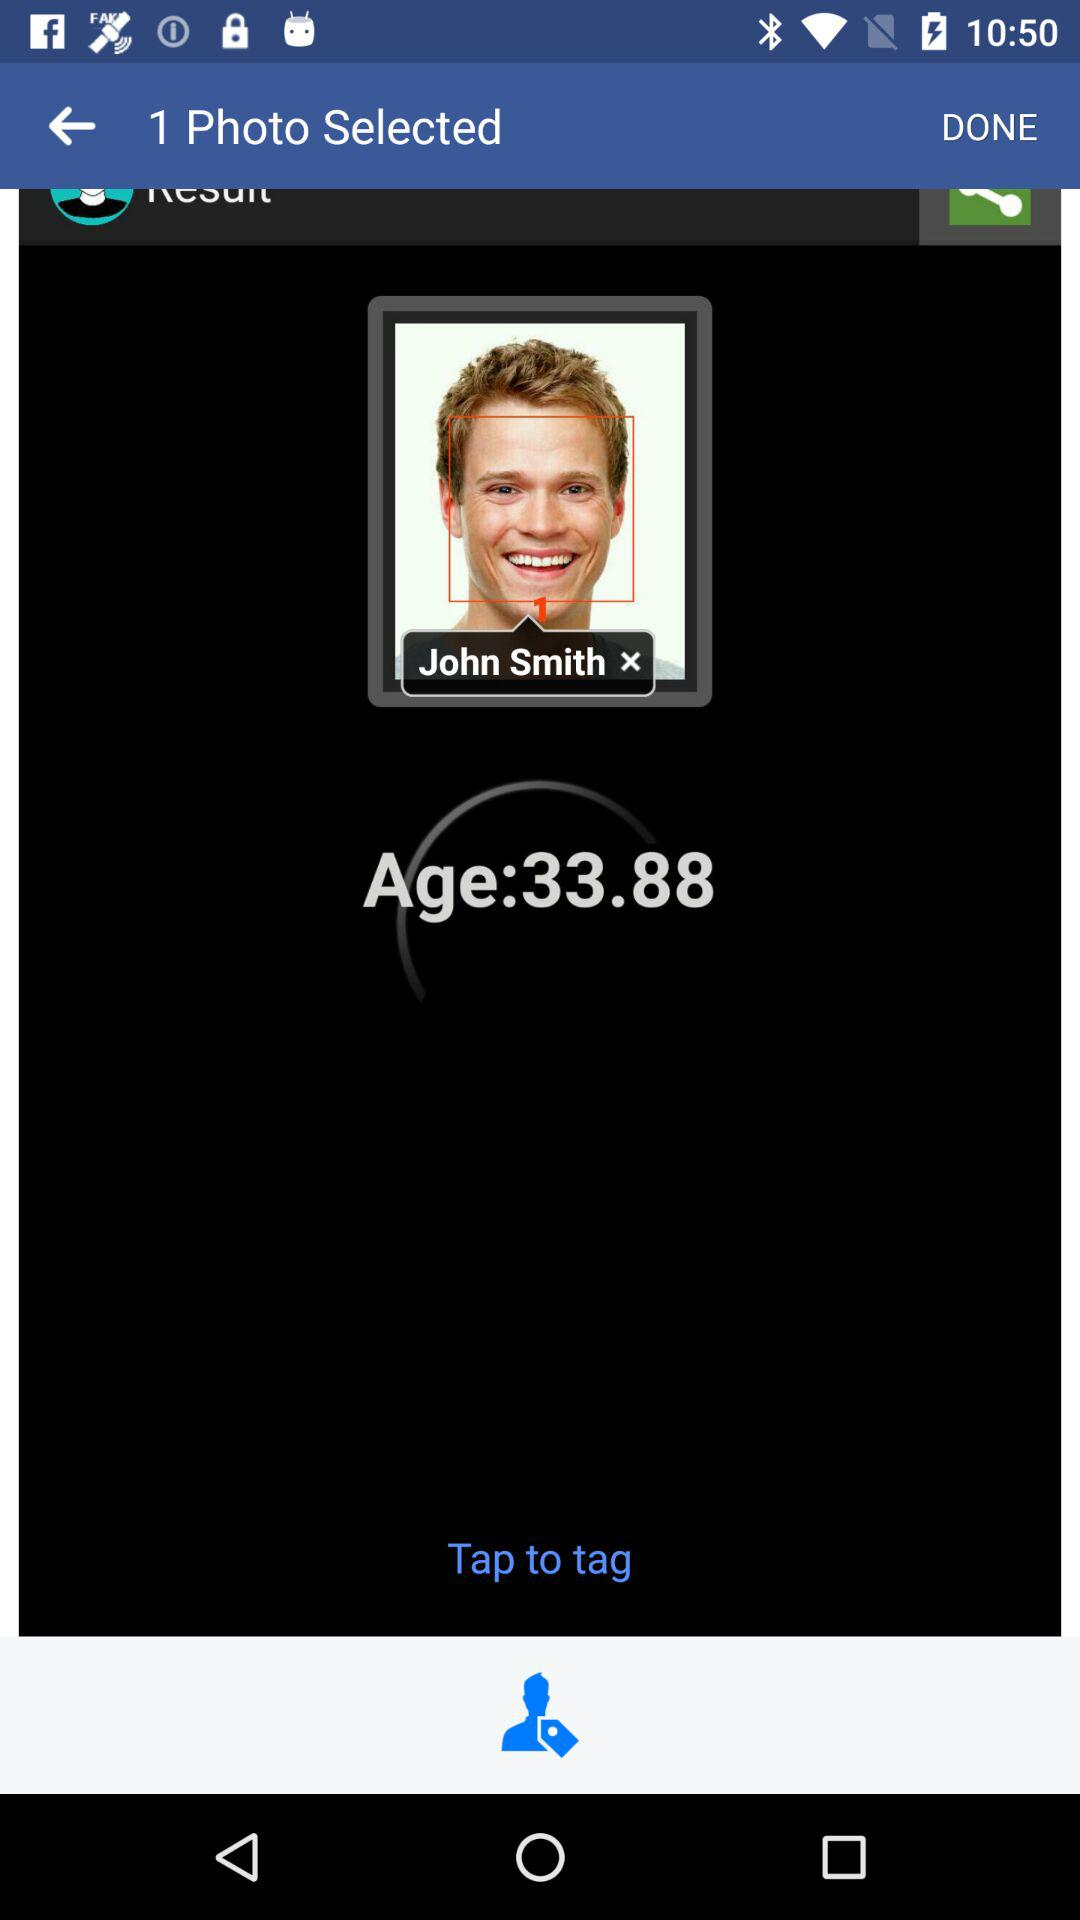How many people are in the photo?
Answer the question using a single word or phrase. 1 